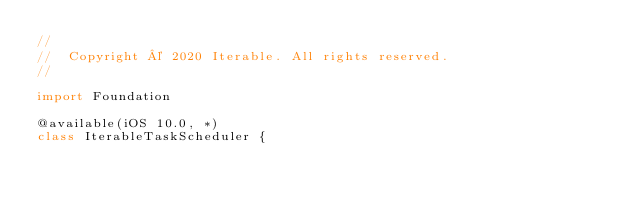<code> <loc_0><loc_0><loc_500><loc_500><_Swift_>//
//  Copyright © 2020 Iterable. All rights reserved.
//

import Foundation

@available(iOS 10.0, *)
class IterableTaskScheduler {</code> 